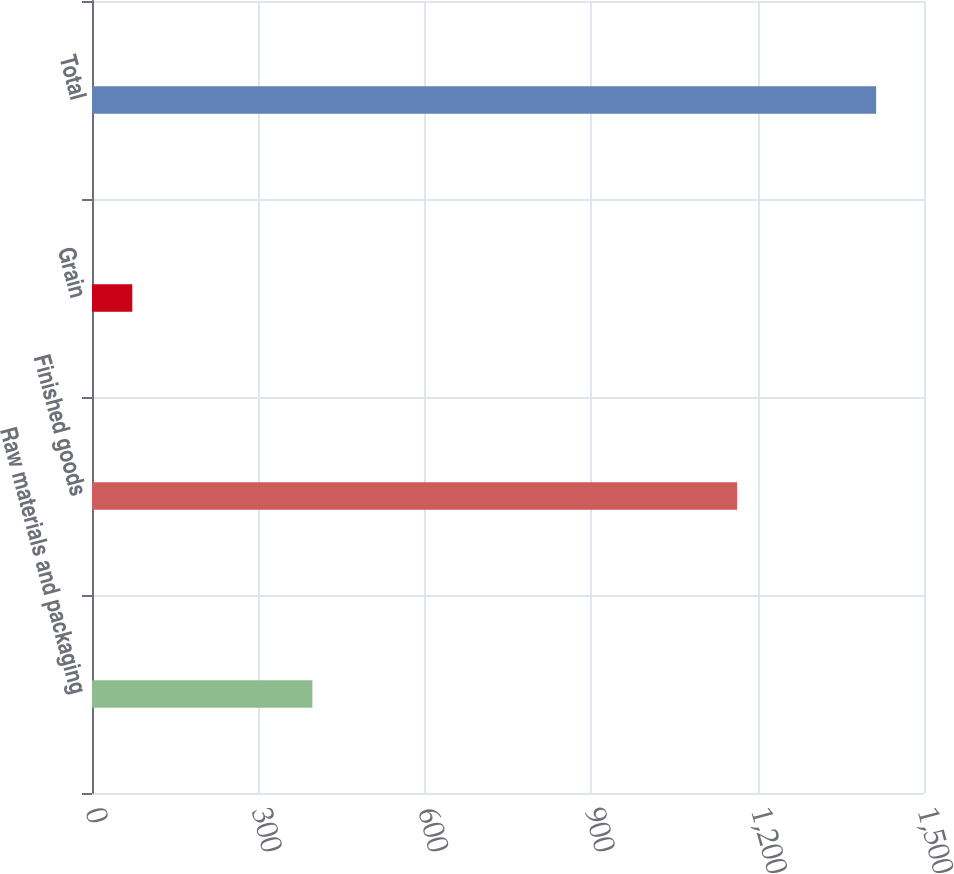<chart> <loc_0><loc_0><loc_500><loc_500><bar_chart><fcel>Raw materials and packaging<fcel>Finished goods<fcel>Grain<fcel>Total<nl><fcel>397.3<fcel>1163.1<fcel>72.6<fcel>1413.7<nl></chart> 